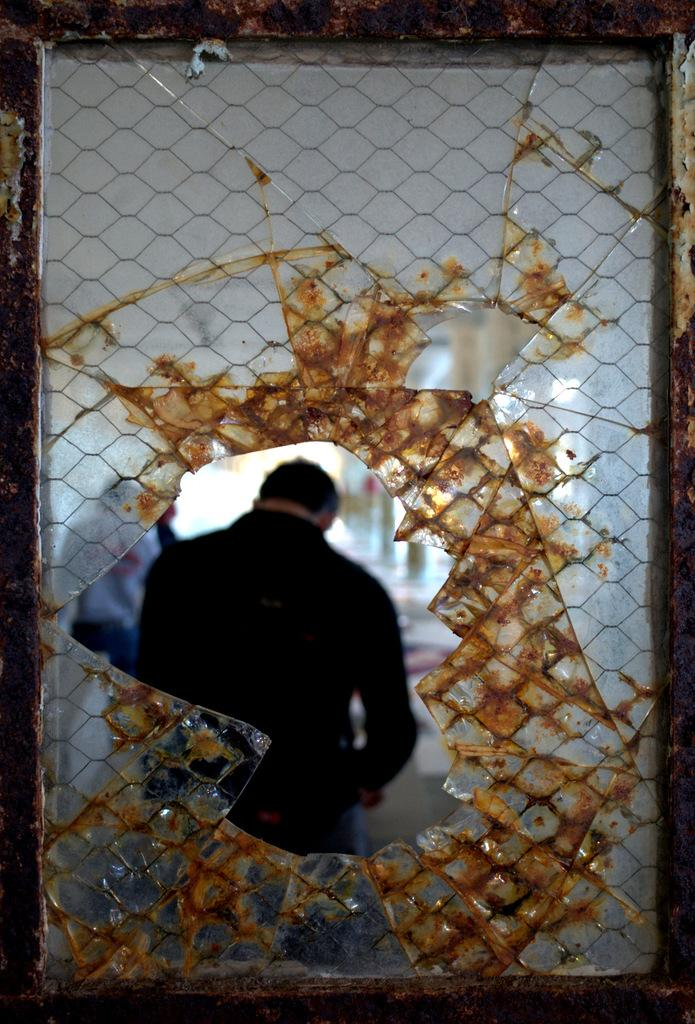What object is visible in the image? There is a glass in the image. What is happening with the people in the image? The people are standing behind the glass. Where are the people located in relation to the glass? The people are on the floor. Can you describe any other visual elements in the image? There are blurred items in the image. What type of flowers can be seen growing in the air in the image? There are no flowers visible in the image, and the concept of flowers growing in the air is not applicable to the given facts. 